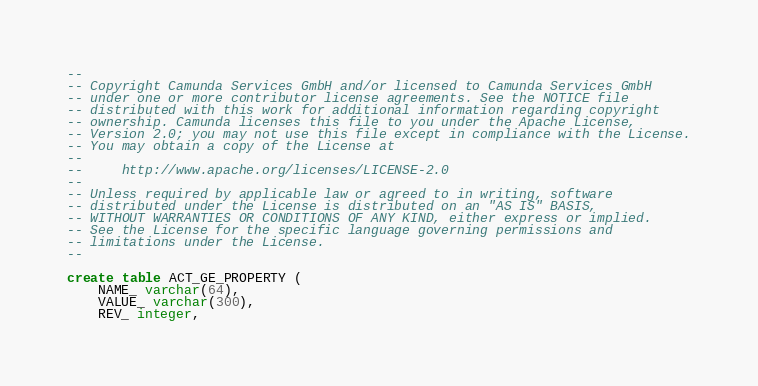<code> <loc_0><loc_0><loc_500><loc_500><_SQL_>--
-- Copyright Camunda Services GmbH and/or licensed to Camunda Services GmbH
-- under one or more contributor license agreements. See the NOTICE file
-- distributed with this work for additional information regarding copyright
-- ownership. Camunda licenses this file to you under the Apache License,
-- Version 2.0; you may not use this file except in compliance with the License.
-- You may obtain a copy of the License at
--
--     http://www.apache.org/licenses/LICENSE-2.0
--
-- Unless required by applicable law or agreed to in writing, software
-- distributed under the License is distributed on an "AS IS" BASIS,
-- WITHOUT WARRANTIES OR CONDITIONS OF ANY KIND, either express or implied.
-- See the License for the specific language governing permissions and
-- limitations under the License.
--

create table ACT_GE_PROPERTY (
    NAME_ varchar(64),
    VALUE_ varchar(300),
    REV_ integer,</code> 